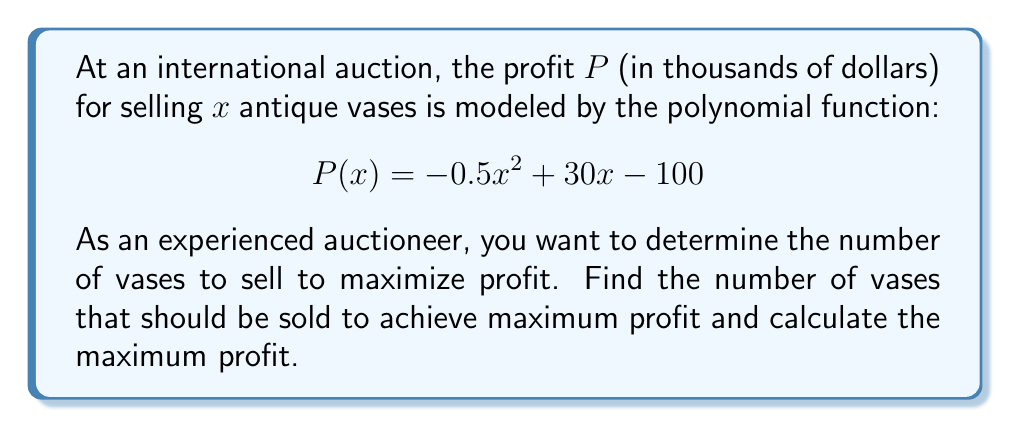Help me with this question. To solve this problem, we'll follow these steps:

1) The profit function $P(x)$ is a quadratic function, which forms a parabola when graphed. The maximum point of this parabola represents the maximum profit.

2) To find the maximum point, we need to find the vertex of the parabola. For a quadratic function in the form $f(x) = ax^2 + bx + c$, the x-coordinate of the vertex is given by $x = -\frac{b}{2a}$.

3) In our function $P(x) = -0.5x^2 + 30x - 100$, we have:
   $a = -0.5$
   $b = 30$
   $c = -100$

4) Applying the formula:
   $x = -\frac{b}{2a} = -\frac{30}{2(-0.5)} = -\frac{30}{-1} = 30$

5) This means the maximum profit occurs when 30 vases are sold.

6) To find the maximum profit, we substitute $x = 30$ into the original function:

   $P(30) = -0.5(30)^2 + 30(30) - 100$
          $= -0.5(900) + 900 - 100$
          $= -450 + 900 - 100$
          $= 350$

7) Therefore, the maximum profit is $350,000.

[asy]
import graph;
size(200,200);
real f(real x) {return -0.5*x^2 + 30*x - 100;}
draw(graph(f,0,60),blue);
dot((30,350),red);
label("(30, 350)",right,(30,350),red);
xaxis("x",arrow=Arrow);
yaxis("P(x)",arrow=Arrow);
[/asy]
Answer: The maximum profit is achieved by selling 30 vases, resulting in a profit of $350,000. 